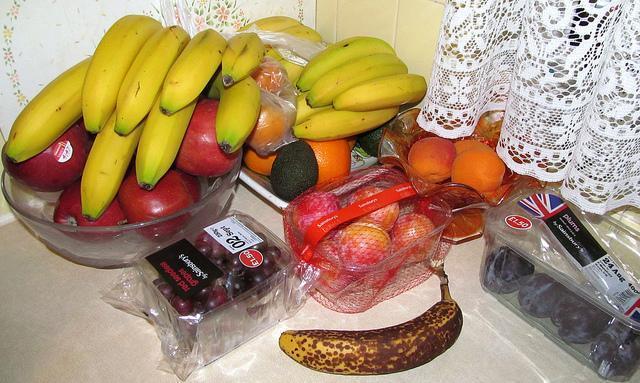How many bananas are there?
Give a very brief answer. 5. How many apples are there?
Give a very brief answer. 2. 